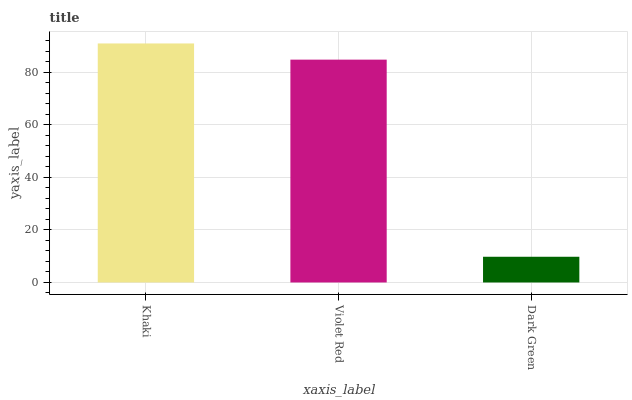Is Dark Green the minimum?
Answer yes or no. Yes. Is Khaki the maximum?
Answer yes or no. Yes. Is Violet Red the minimum?
Answer yes or no. No. Is Violet Red the maximum?
Answer yes or no. No. Is Khaki greater than Violet Red?
Answer yes or no. Yes. Is Violet Red less than Khaki?
Answer yes or no. Yes. Is Violet Red greater than Khaki?
Answer yes or no. No. Is Khaki less than Violet Red?
Answer yes or no. No. Is Violet Red the high median?
Answer yes or no. Yes. Is Violet Red the low median?
Answer yes or no. Yes. Is Khaki the high median?
Answer yes or no. No. Is Khaki the low median?
Answer yes or no. No. 